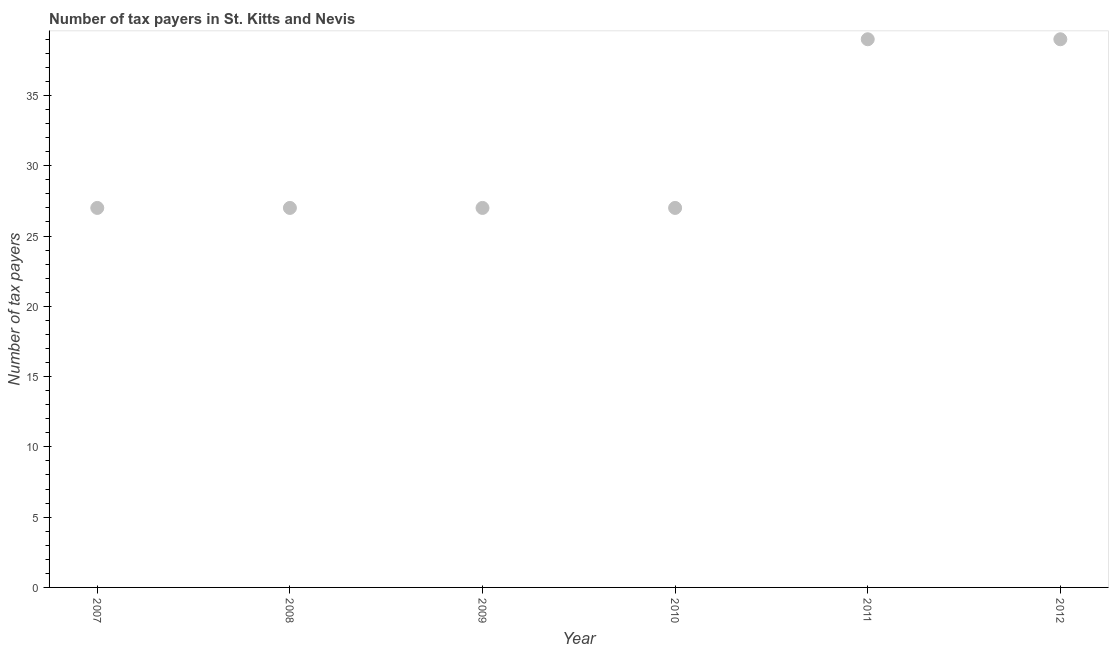What is the number of tax payers in 2012?
Your answer should be very brief. 39. Across all years, what is the maximum number of tax payers?
Your answer should be compact. 39. Across all years, what is the minimum number of tax payers?
Your answer should be very brief. 27. In which year was the number of tax payers maximum?
Make the answer very short. 2011. What is the sum of the number of tax payers?
Offer a terse response. 186. What is the average number of tax payers per year?
Provide a succinct answer. 31. In how many years, is the number of tax payers greater than 12 ?
Your answer should be compact. 6. What is the ratio of the number of tax payers in 2010 to that in 2012?
Provide a short and direct response. 0.69. What is the difference between the highest and the second highest number of tax payers?
Provide a succinct answer. 0. What is the difference between the highest and the lowest number of tax payers?
Offer a terse response. 12. In how many years, is the number of tax payers greater than the average number of tax payers taken over all years?
Ensure brevity in your answer.  2. What is the difference between two consecutive major ticks on the Y-axis?
Provide a succinct answer. 5. Are the values on the major ticks of Y-axis written in scientific E-notation?
Your response must be concise. No. Does the graph contain any zero values?
Offer a terse response. No. What is the title of the graph?
Make the answer very short. Number of tax payers in St. Kitts and Nevis. What is the label or title of the X-axis?
Your answer should be compact. Year. What is the label or title of the Y-axis?
Make the answer very short. Number of tax payers. What is the Number of tax payers in 2008?
Your answer should be very brief. 27. What is the Number of tax payers in 2009?
Give a very brief answer. 27. What is the Number of tax payers in 2010?
Provide a succinct answer. 27. What is the difference between the Number of tax payers in 2007 and 2009?
Offer a terse response. 0. What is the difference between the Number of tax payers in 2007 and 2010?
Your answer should be very brief. 0. What is the difference between the Number of tax payers in 2008 and 2009?
Your answer should be compact. 0. What is the difference between the Number of tax payers in 2008 and 2011?
Your answer should be compact. -12. What is the difference between the Number of tax payers in 2008 and 2012?
Your answer should be compact. -12. What is the difference between the Number of tax payers in 2010 and 2012?
Offer a terse response. -12. What is the difference between the Number of tax payers in 2011 and 2012?
Make the answer very short. 0. What is the ratio of the Number of tax payers in 2007 to that in 2008?
Give a very brief answer. 1. What is the ratio of the Number of tax payers in 2007 to that in 2011?
Offer a terse response. 0.69. What is the ratio of the Number of tax payers in 2007 to that in 2012?
Your answer should be compact. 0.69. What is the ratio of the Number of tax payers in 2008 to that in 2009?
Make the answer very short. 1. What is the ratio of the Number of tax payers in 2008 to that in 2010?
Your answer should be compact. 1. What is the ratio of the Number of tax payers in 2008 to that in 2011?
Ensure brevity in your answer.  0.69. What is the ratio of the Number of tax payers in 2008 to that in 2012?
Offer a terse response. 0.69. What is the ratio of the Number of tax payers in 2009 to that in 2010?
Offer a terse response. 1. What is the ratio of the Number of tax payers in 2009 to that in 2011?
Make the answer very short. 0.69. What is the ratio of the Number of tax payers in 2009 to that in 2012?
Ensure brevity in your answer.  0.69. What is the ratio of the Number of tax payers in 2010 to that in 2011?
Ensure brevity in your answer.  0.69. What is the ratio of the Number of tax payers in 2010 to that in 2012?
Make the answer very short. 0.69. What is the ratio of the Number of tax payers in 2011 to that in 2012?
Keep it short and to the point. 1. 